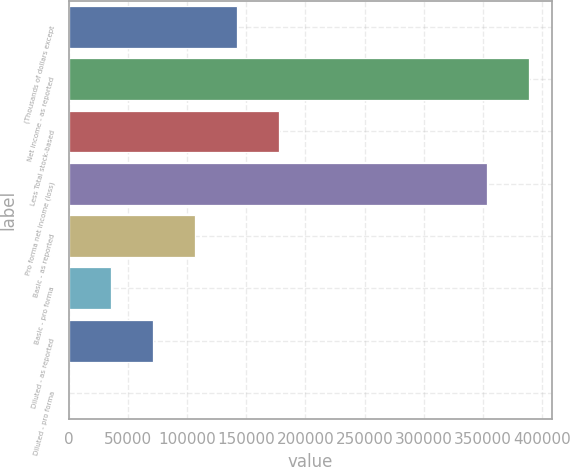<chart> <loc_0><loc_0><loc_500><loc_500><bar_chart><fcel>(Thousands of dollars except<fcel>Net income - as reported<fcel>Less Total stock-based<fcel>Pro forma net income (loss)<fcel>Basic - as reported<fcel>Basic - pro forma<fcel>Diluted - as reported<fcel>Diluted - pro forma<nl><fcel>142385<fcel>389218<fcel>177981<fcel>353622<fcel>106789<fcel>35596.9<fcel>71192.9<fcel>0.86<nl></chart> 